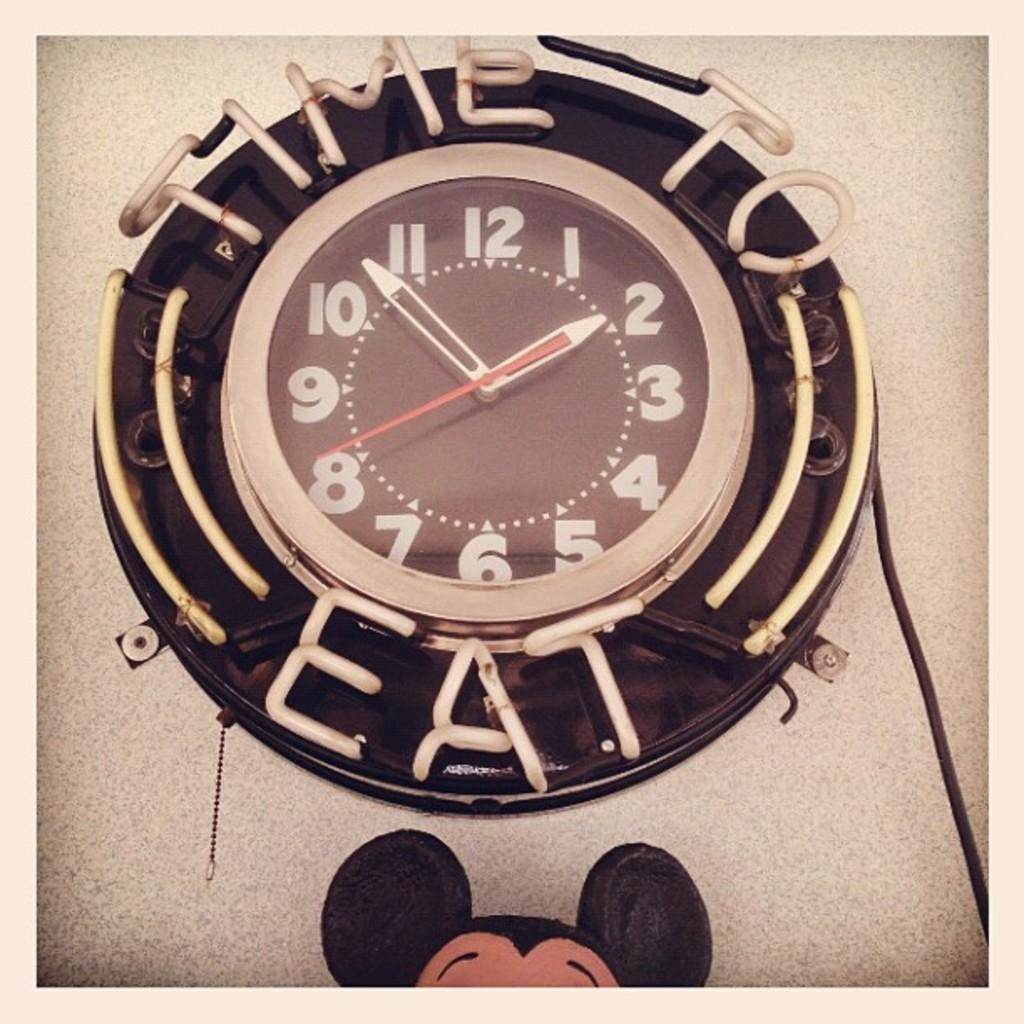<image>
Give a short and clear explanation of the subsequent image. A clock says it's time to eat with a time of 1:54. 